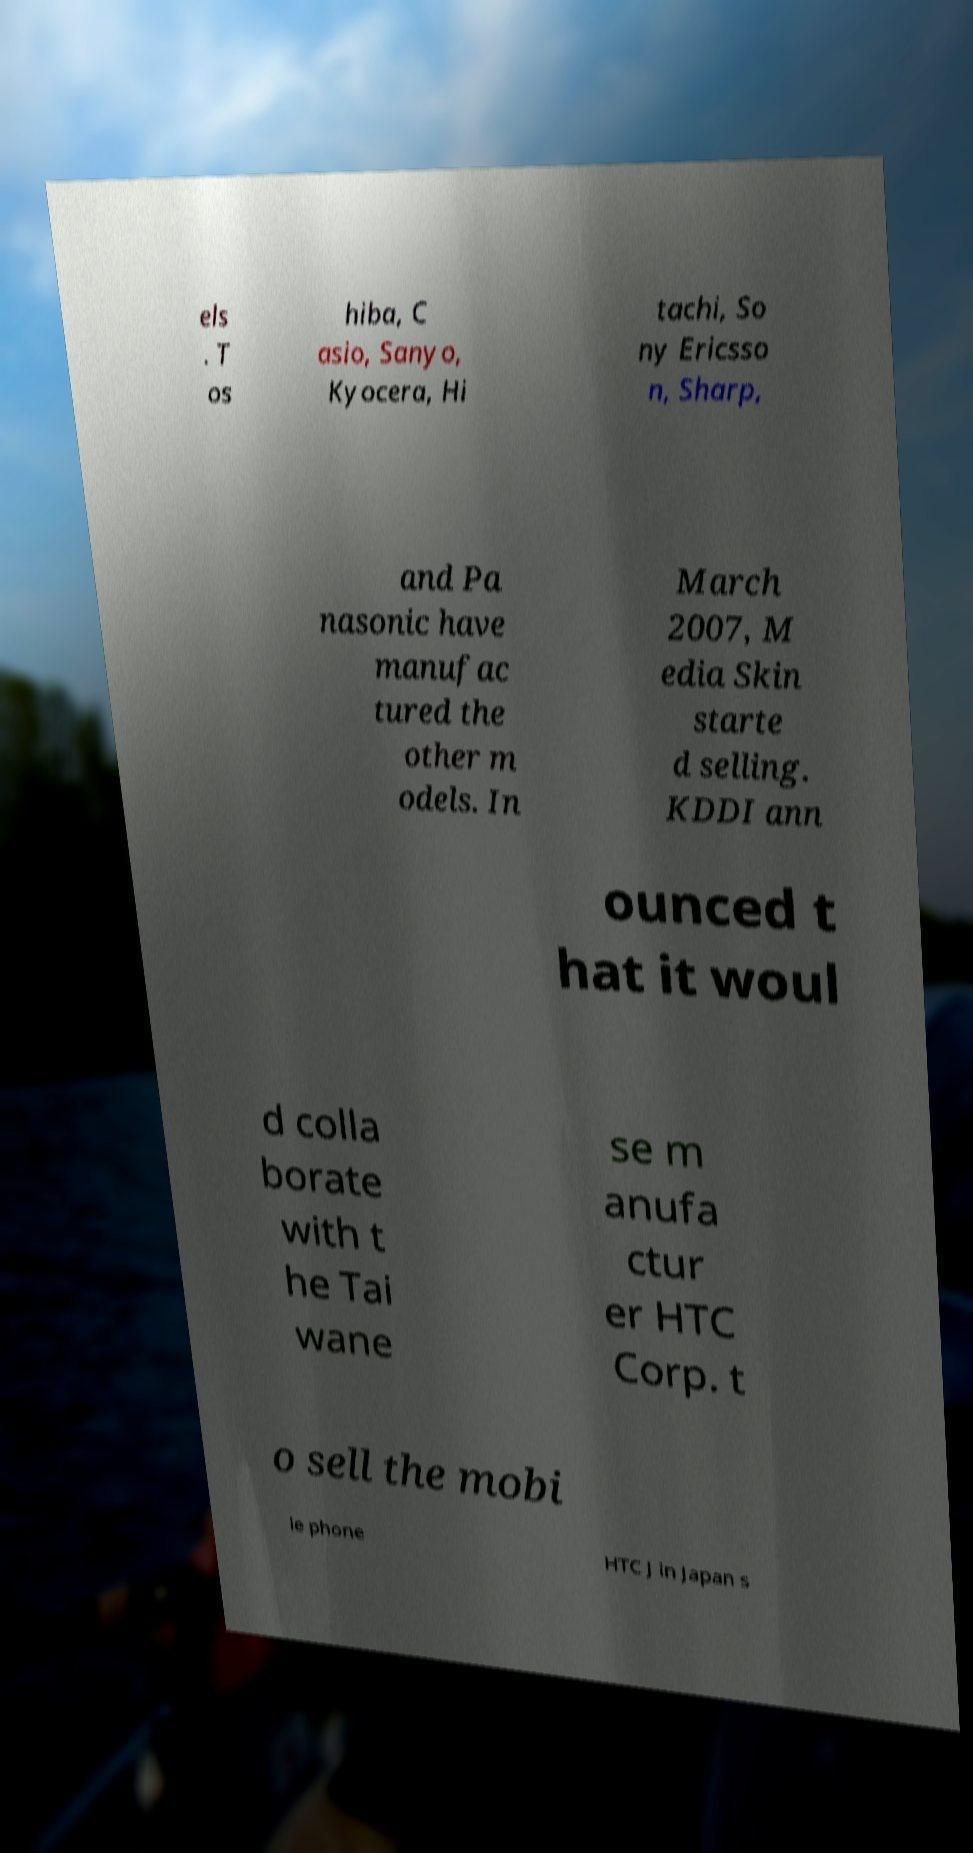I need the written content from this picture converted into text. Can you do that? els . T os hiba, C asio, Sanyo, Kyocera, Hi tachi, So ny Ericsso n, Sharp, and Pa nasonic have manufac tured the other m odels. In March 2007, M edia Skin starte d selling. KDDI ann ounced t hat it woul d colla borate with t he Tai wane se m anufa ctur er HTC Corp. t o sell the mobi le phone HTC J in Japan s 